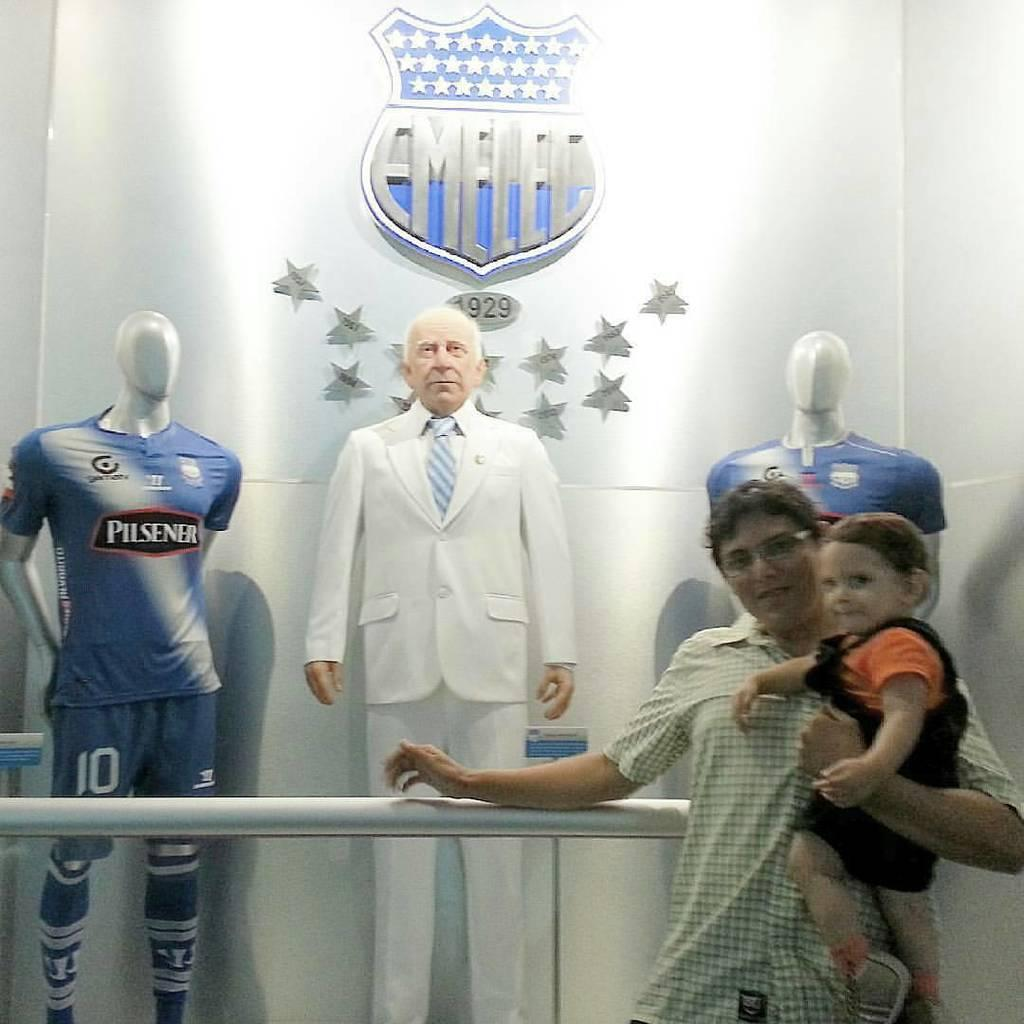Provide a one-sentence caption for the provided image. one of the models is wearing a Pilsener jersey. 